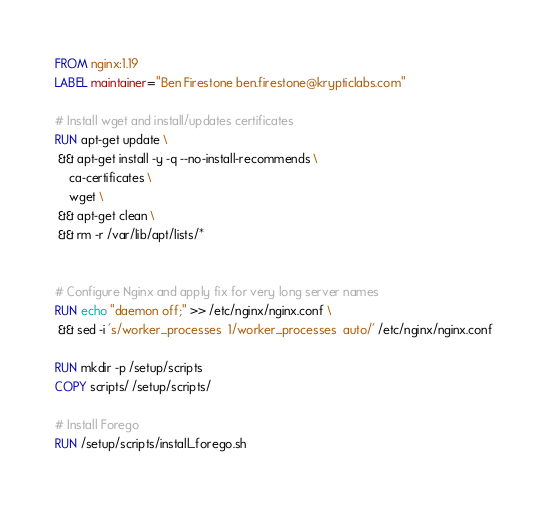<code> <loc_0><loc_0><loc_500><loc_500><_Dockerfile_>FROM nginx:1.19
LABEL maintainer="Ben Firestone ben.firestone@krypticlabs.com"

# Install wget and install/updates certificates
RUN apt-get update \
 && apt-get install -y -q --no-install-recommends \
    ca-certificates \
    wget \
 && apt-get clean \
 && rm -r /var/lib/apt/lists/*


# Configure Nginx and apply fix for very long server names
RUN echo "daemon off;" >> /etc/nginx/nginx.conf \
 && sed -i 's/worker_processes  1/worker_processes  auto/' /etc/nginx/nginx.conf

RUN mkdir -p /setup/scripts
COPY scripts/ /setup/scripts/

# Install Forego
RUN /setup/scripts/install_forego.sh
</code> 